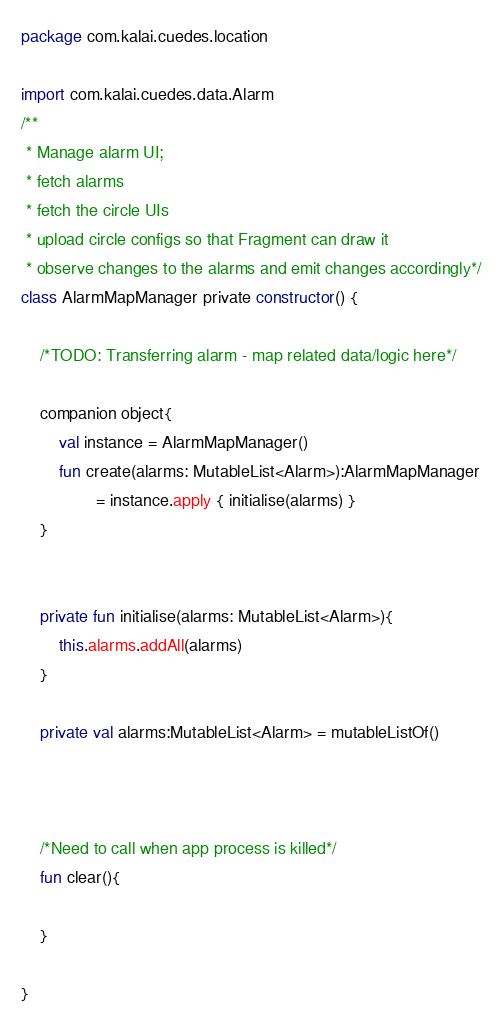Convert code to text. <code><loc_0><loc_0><loc_500><loc_500><_Kotlin_>package com.kalai.cuedes.location

import com.kalai.cuedes.data.Alarm
/**
 * Manage alarm UI;
 * fetch alarms
 * fetch the circle UIs
 * upload circle configs so that Fragment can draw it
 * observe changes to the alarms and emit changes accordingly*/
class AlarmMapManager private constructor() {

    /*TODO: Transferring alarm - map related data/logic here*/

    companion object{
        val instance = AlarmMapManager()
        fun create(alarms: MutableList<Alarm>):AlarmMapManager
                = instance.apply { initialise(alarms) }
    }


    private fun initialise(alarms: MutableList<Alarm>){
        this.alarms.addAll(alarms)
    }

    private val alarms:MutableList<Alarm> = mutableListOf()



    /*Need to call when app process is killed*/
    fun clear(){

    }

}</code> 